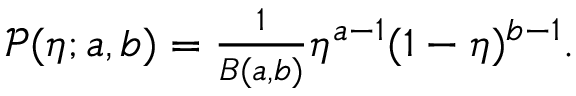<formula> <loc_0><loc_0><loc_500><loc_500>\begin{array} { r } { \mathcal { P } ( \eta ; a , b ) = \frac { 1 } { B ( a , b ) } \eta ^ { a - 1 } ( 1 - \eta ) ^ { b - 1 } . } \end{array}</formula> 